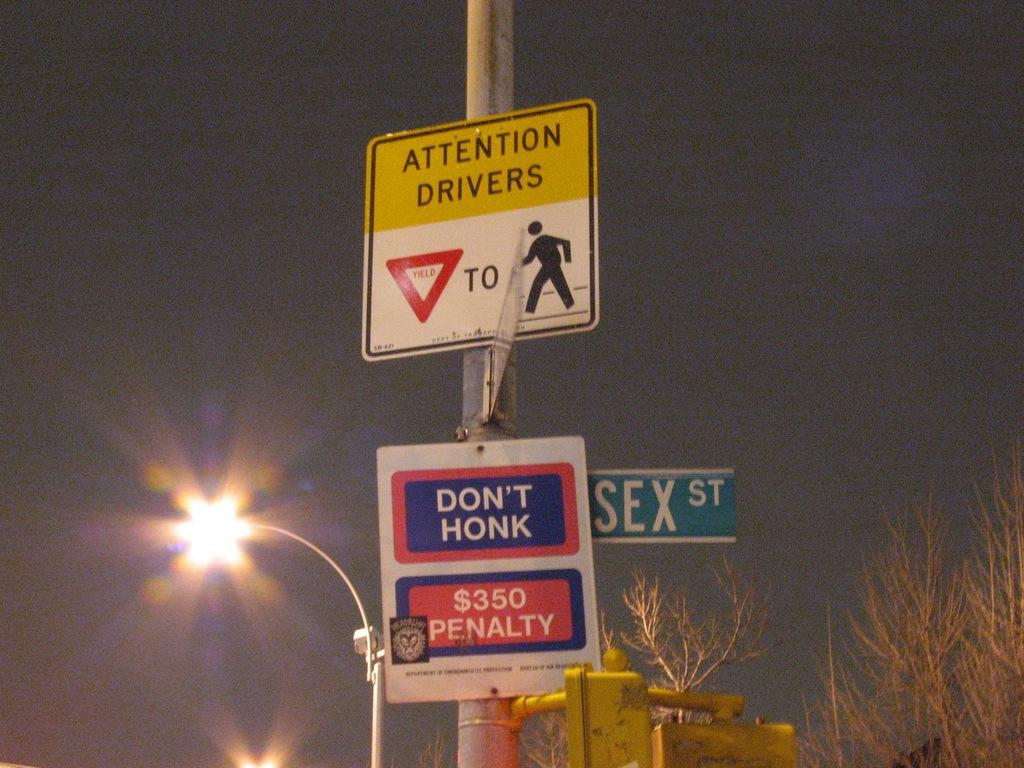<image>
Offer a succinct explanation of the picture presented. Below a street sign alerting drivers to yield for pedestrians is a sign instructing drivers not to honk or they will be fined $350. 